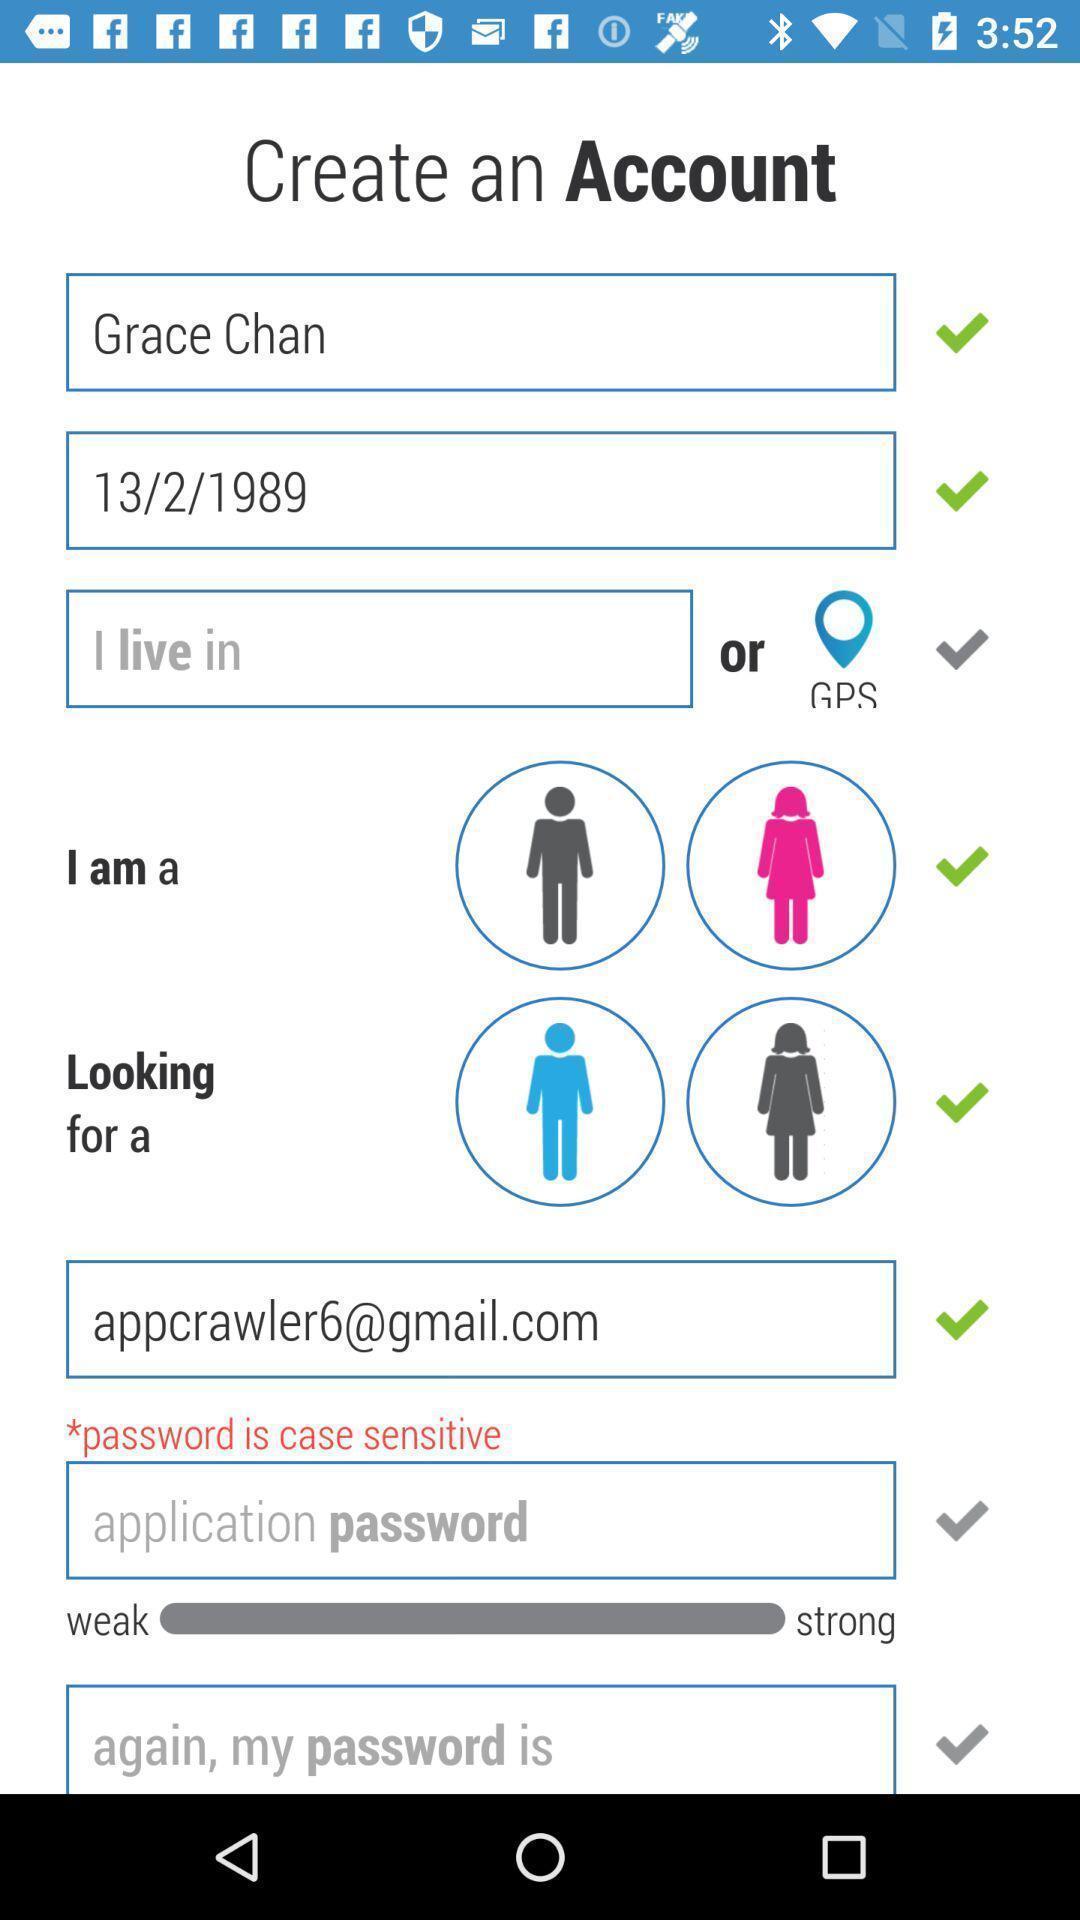Give me a narrative description of this picture. Page for creating an account. 